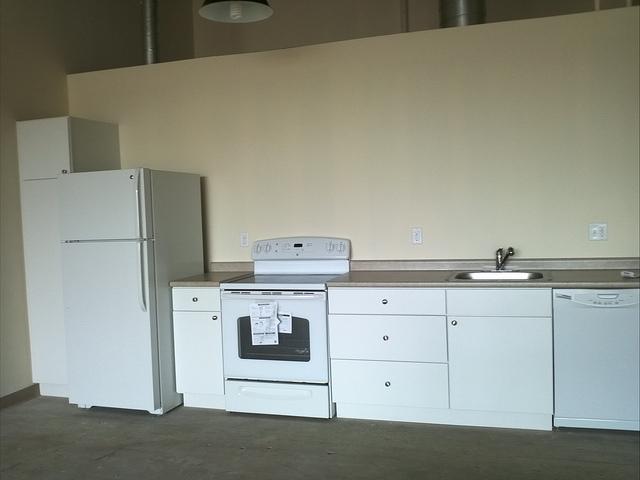How many drawers are next to the fridge?
Quick response, please. 1. Are the drawers white?
Quick response, please. Yes. What color is the hardware on the cabinets?
Concise answer only. Silver. What is the object next to the refrigerator?
Keep it brief. Cabinet. Is this room a dining room, a kitchen, or a bedroom?
Short answer required. Kitchen. Where is the fridge?
Give a very brief answer. Left. Is this a painting?
Give a very brief answer. No. What color is the E4 on the box?
Give a very brief answer. White. What appliance is to the right of the stove?
Answer briefly. Dishwasher. Is there a fridge?
Concise answer only. Yes. Is the stove new?
Quick response, please. Yes. Which drawer is open?
Give a very brief answer. None. 